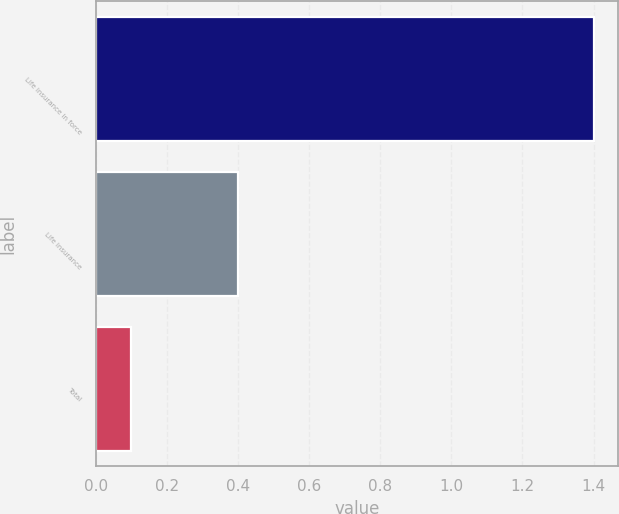Convert chart. <chart><loc_0><loc_0><loc_500><loc_500><bar_chart><fcel>Life insurance in force<fcel>Life insurance<fcel>Total<nl><fcel>1.4<fcel>0.4<fcel>0.1<nl></chart> 